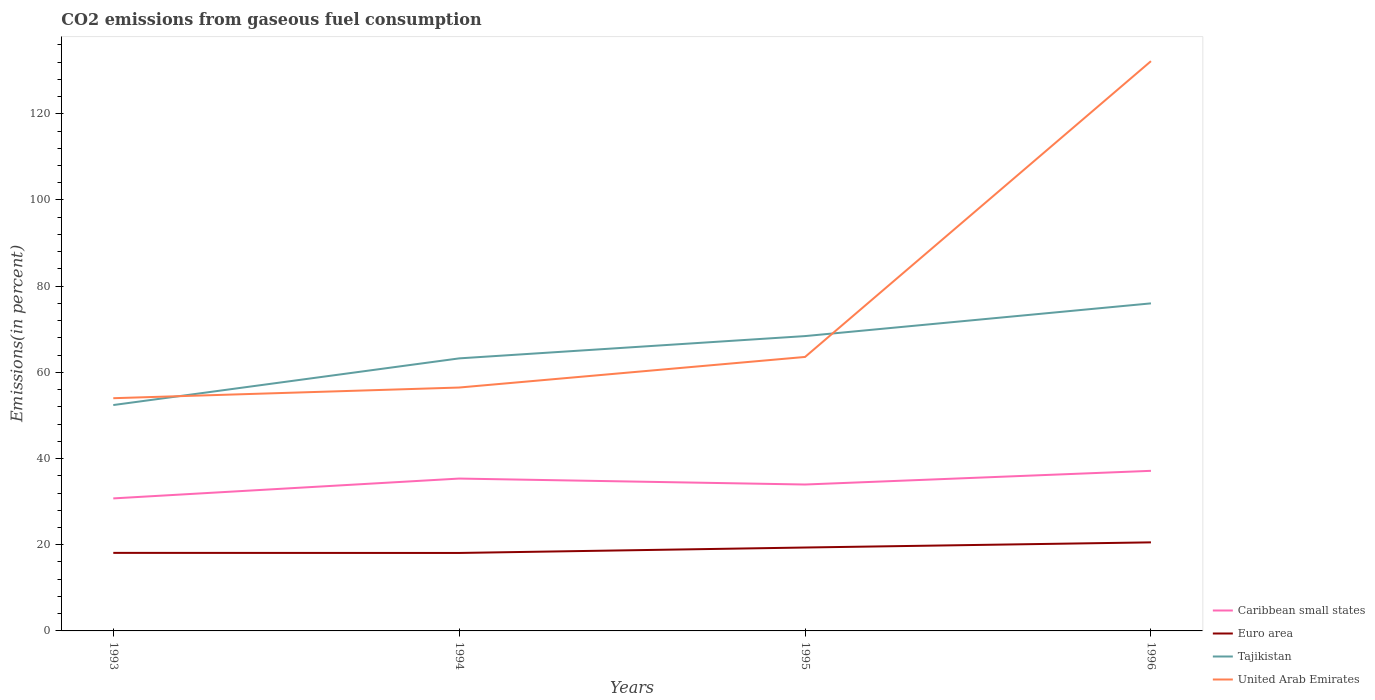How many different coloured lines are there?
Your answer should be very brief. 4. Does the line corresponding to Tajikistan intersect with the line corresponding to United Arab Emirates?
Offer a very short reply. Yes. Across all years, what is the maximum total CO2 emitted in Euro area?
Your response must be concise. 18.09. In which year was the total CO2 emitted in United Arab Emirates maximum?
Ensure brevity in your answer.  1993. What is the total total CO2 emitted in United Arab Emirates in the graph?
Keep it short and to the point. -2.48. What is the difference between the highest and the second highest total CO2 emitted in United Arab Emirates?
Ensure brevity in your answer.  78.21. How many years are there in the graph?
Provide a short and direct response. 4. What is the difference between two consecutive major ticks on the Y-axis?
Offer a terse response. 20. Are the values on the major ticks of Y-axis written in scientific E-notation?
Give a very brief answer. No. Where does the legend appear in the graph?
Your answer should be very brief. Bottom right. How many legend labels are there?
Provide a succinct answer. 4. How are the legend labels stacked?
Offer a very short reply. Vertical. What is the title of the graph?
Provide a succinct answer. CO2 emissions from gaseous fuel consumption. Does "Congo (Republic)" appear as one of the legend labels in the graph?
Your response must be concise. No. What is the label or title of the Y-axis?
Your response must be concise. Emissions(in percent). What is the Emissions(in percent) of Caribbean small states in 1993?
Give a very brief answer. 30.75. What is the Emissions(in percent) in Euro area in 1993?
Give a very brief answer. 18.11. What is the Emissions(in percent) in Tajikistan in 1993?
Keep it short and to the point. 52.41. What is the Emissions(in percent) of United Arab Emirates in 1993?
Ensure brevity in your answer.  54. What is the Emissions(in percent) in Caribbean small states in 1994?
Your response must be concise. 35.35. What is the Emissions(in percent) of Euro area in 1994?
Provide a short and direct response. 18.09. What is the Emissions(in percent) of Tajikistan in 1994?
Give a very brief answer. 63.24. What is the Emissions(in percent) in United Arab Emirates in 1994?
Make the answer very short. 56.48. What is the Emissions(in percent) of Caribbean small states in 1995?
Offer a terse response. 33.97. What is the Emissions(in percent) of Euro area in 1995?
Your answer should be compact. 19.35. What is the Emissions(in percent) of Tajikistan in 1995?
Your answer should be very brief. 68.41. What is the Emissions(in percent) of United Arab Emirates in 1995?
Your response must be concise. 63.57. What is the Emissions(in percent) in Caribbean small states in 1996?
Give a very brief answer. 37.15. What is the Emissions(in percent) of Euro area in 1996?
Give a very brief answer. 20.55. What is the Emissions(in percent) in Tajikistan in 1996?
Provide a succinct answer. 76.01. What is the Emissions(in percent) in United Arab Emirates in 1996?
Your answer should be compact. 132.21. Across all years, what is the maximum Emissions(in percent) in Caribbean small states?
Provide a succinct answer. 37.15. Across all years, what is the maximum Emissions(in percent) in Euro area?
Provide a succinct answer. 20.55. Across all years, what is the maximum Emissions(in percent) in Tajikistan?
Your answer should be very brief. 76.01. Across all years, what is the maximum Emissions(in percent) of United Arab Emirates?
Provide a succinct answer. 132.21. Across all years, what is the minimum Emissions(in percent) of Caribbean small states?
Make the answer very short. 30.75. Across all years, what is the minimum Emissions(in percent) in Euro area?
Offer a terse response. 18.09. Across all years, what is the minimum Emissions(in percent) in Tajikistan?
Provide a succinct answer. 52.41. Across all years, what is the minimum Emissions(in percent) of United Arab Emirates?
Make the answer very short. 54. What is the total Emissions(in percent) of Caribbean small states in the graph?
Keep it short and to the point. 137.22. What is the total Emissions(in percent) in Euro area in the graph?
Your response must be concise. 76.1. What is the total Emissions(in percent) of Tajikistan in the graph?
Your answer should be compact. 260.07. What is the total Emissions(in percent) of United Arab Emirates in the graph?
Give a very brief answer. 306.25. What is the difference between the Emissions(in percent) in Caribbean small states in 1993 and that in 1994?
Offer a very short reply. -4.6. What is the difference between the Emissions(in percent) of Euro area in 1993 and that in 1994?
Make the answer very short. 0.02. What is the difference between the Emissions(in percent) of Tajikistan in 1993 and that in 1994?
Your answer should be compact. -10.83. What is the difference between the Emissions(in percent) in United Arab Emirates in 1993 and that in 1994?
Ensure brevity in your answer.  -2.48. What is the difference between the Emissions(in percent) in Caribbean small states in 1993 and that in 1995?
Give a very brief answer. -3.22. What is the difference between the Emissions(in percent) of Euro area in 1993 and that in 1995?
Give a very brief answer. -1.24. What is the difference between the Emissions(in percent) of Tajikistan in 1993 and that in 1995?
Ensure brevity in your answer.  -16. What is the difference between the Emissions(in percent) in United Arab Emirates in 1993 and that in 1995?
Your answer should be very brief. -9.58. What is the difference between the Emissions(in percent) of Caribbean small states in 1993 and that in 1996?
Your response must be concise. -6.4. What is the difference between the Emissions(in percent) of Euro area in 1993 and that in 1996?
Offer a terse response. -2.44. What is the difference between the Emissions(in percent) of Tajikistan in 1993 and that in 1996?
Offer a terse response. -23.59. What is the difference between the Emissions(in percent) in United Arab Emirates in 1993 and that in 1996?
Your response must be concise. -78.21. What is the difference between the Emissions(in percent) in Caribbean small states in 1994 and that in 1995?
Provide a succinct answer. 1.38. What is the difference between the Emissions(in percent) in Euro area in 1994 and that in 1995?
Your answer should be very brief. -1.26. What is the difference between the Emissions(in percent) of Tajikistan in 1994 and that in 1995?
Make the answer very short. -5.17. What is the difference between the Emissions(in percent) in United Arab Emirates in 1994 and that in 1995?
Offer a terse response. -7.1. What is the difference between the Emissions(in percent) in Caribbean small states in 1994 and that in 1996?
Offer a very short reply. -1.79. What is the difference between the Emissions(in percent) in Euro area in 1994 and that in 1996?
Make the answer very short. -2.46. What is the difference between the Emissions(in percent) of Tajikistan in 1994 and that in 1996?
Make the answer very short. -12.77. What is the difference between the Emissions(in percent) in United Arab Emirates in 1994 and that in 1996?
Offer a very short reply. -75.73. What is the difference between the Emissions(in percent) of Caribbean small states in 1995 and that in 1996?
Provide a short and direct response. -3.18. What is the difference between the Emissions(in percent) of Euro area in 1995 and that in 1996?
Give a very brief answer. -1.2. What is the difference between the Emissions(in percent) of Tajikistan in 1995 and that in 1996?
Give a very brief answer. -7.59. What is the difference between the Emissions(in percent) of United Arab Emirates in 1995 and that in 1996?
Offer a terse response. -68.63. What is the difference between the Emissions(in percent) of Caribbean small states in 1993 and the Emissions(in percent) of Euro area in 1994?
Offer a terse response. 12.66. What is the difference between the Emissions(in percent) of Caribbean small states in 1993 and the Emissions(in percent) of Tajikistan in 1994?
Ensure brevity in your answer.  -32.49. What is the difference between the Emissions(in percent) in Caribbean small states in 1993 and the Emissions(in percent) in United Arab Emirates in 1994?
Provide a short and direct response. -25.73. What is the difference between the Emissions(in percent) of Euro area in 1993 and the Emissions(in percent) of Tajikistan in 1994?
Offer a terse response. -45.13. What is the difference between the Emissions(in percent) in Euro area in 1993 and the Emissions(in percent) in United Arab Emirates in 1994?
Your answer should be very brief. -38.37. What is the difference between the Emissions(in percent) in Tajikistan in 1993 and the Emissions(in percent) in United Arab Emirates in 1994?
Your response must be concise. -4.06. What is the difference between the Emissions(in percent) of Caribbean small states in 1993 and the Emissions(in percent) of Euro area in 1995?
Give a very brief answer. 11.4. What is the difference between the Emissions(in percent) of Caribbean small states in 1993 and the Emissions(in percent) of Tajikistan in 1995?
Your response must be concise. -37.66. What is the difference between the Emissions(in percent) in Caribbean small states in 1993 and the Emissions(in percent) in United Arab Emirates in 1995?
Provide a short and direct response. -32.83. What is the difference between the Emissions(in percent) in Euro area in 1993 and the Emissions(in percent) in Tajikistan in 1995?
Your response must be concise. -50.3. What is the difference between the Emissions(in percent) in Euro area in 1993 and the Emissions(in percent) in United Arab Emirates in 1995?
Ensure brevity in your answer.  -45.47. What is the difference between the Emissions(in percent) of Tajikistan in 1993 and the Emissions(in percent) of United Arab Emirates in 1995?
Offer a very short reply. -11.16. What is the difference between the Emissions(in percent) in Caribbean small states in 1993 and the Emissions(in percent) in Euro area in 1996?
Your answer should be very brief. 10.2. What is the difference between the Emissions(in percent) of Caribbean small states in 1993 and the Emissions(in percent) of Tajikistan in 1996?
Your answer should be compact. -45.26. What is the difference between the Emissions(in percent) of Caribbean small states in 1993 and the Emissions(in percent) of United Arab Emirates in 1996?
Ensure brevity in your answer.  -101.46. What is the difference between the Emissions(in percent) of Euro area in 1993 and the Emissions(in percent) of Tajikistan in 1996?
Your response must be concise. -57.9. What is the difference between the Emissions(in percent) of Euro area in 1993 and the Emissions(in percent) of United Arab Emirates in 1996?
Keep it short and to the point. -114.1. What is the difference between the Emissions(in percent) of Tajikistan in 1993 and the Emissions(in percent) of United Arab Emirates in 1996?
Your answer should be very brief. -79.79. What is the difference between the Emissions(in percent) of Caribbean small states in 1994 and the Emissions(in percent) of Euro area in 1995?
Provide a succinct answer. 16. What is the difference between the Emissions(in percent) in Caribbean small states in 1994 and the Emissions(in percent) in Tajikistan in 1995?
Your response must be concise. -33.06. What is the difference between the Emissions(in percent) of Caribbean small states in 1994 and the Emissions(in percent) of United Arab Emirates in 1995?
Provide a succinct answer. -28.22. What is the difference between the Emissions(in percent) in Euro area in 1994 and the Emissions(in percent) in Tajikistan in 1995?
Offer a very short reply. -50.32. What is the difference between the Emissions(in percent) in Euro area in 1994 and the Emissions(in percent) in United Arab Emirates in 1995?
Your answer should be very brief. -45.48. What is the difference between the Emissions(in percent) in Tajikistan in 1994 and the Emissions(in percent) in United Arab Emirates in 1995?
Keep it short and to the point. -0.33. What is the difference between the Emissions(in percent) of Caribbean small states in 1994 and the Emissions(in percent) of Euro area in 1996?
Provide a short and direct response. 14.8. What is the difference between the Emissions(in percent) of Caribbean small states in 1994 and the Emissions(in percent) of Tajikistan in 1996?
Offer a terse response. -40.65. What is the difference between the Emissions(in percent) in Caribbean small states in 1994 and the Emissions(in percent) in United Arab Emirates in 1996?
Give a very brief answer. -96.85. What is the difference between the Emissions(in percent) of Euro area in 1994 and the Emissions(in percent) of Tajikistan in 1996?
Keep it short and to the point. -57.91. What is the difference between the Emissions(in percent) of Euro area in 1994 and the Emissions(in percent) of United Arab Emirates in 1996?
Provide a short and direct response. -114.11. What is the difference between the Emissions(in percent) of Tajikistan in 1994 and the Emissions(in percent) of United Arab Emirates in 1996?
Offer a very short reply. -68.97. What is the difference between the Emissions(in percent) in Caribbean small states in 1995 and the Emissions(in percent) in Euro area in 1996?
Make the answer very short. 13.42. What is the difference between the Emissions(in percent) of Caribbean small states in 1995 and the Emissions(in percent) of Tajikistan in 1996?
Provide a succinct answer. -42.03. What is the difference between the Emissions(in percent) in Caribbean small states in 1995 and the Emissions(in percent) in United Arab Emirates in 1996?
Make the answer very short. -98.23. What is the difference between the Emissions(in percent) in Euro area in 1995 and the Emissions(in percent) in Tajikistan in 1996?
Offer a terse response. -56.65. What is the difference between the Emissions(in percent) of Euro area in 1995 and the Emissions(in percent) of United Arab Emirates in 1996?
Your answer should be very brief. -112.85. What is the difference between the Emissions(in percent) of Tajikistan in 1995 and the Emissions(in percent) of United Arab Emirates in 1996?
Your response must be concise. -63.79. What is the average Emissions(in percent) in Caribbean small states per year?
Offer a terse response. 34.3. What is the average Emissions(in percent) in Euro area per year?
Your response must be concise. 19.03. What is the average Emissions(in percent) of Tajikistan per year?
Provide a succinct answer. 65.02. What is the average Emissions(in percent) in United Arab Emirates per year?
Your answer should be very brief. 76.56. In the year 1993, what is the difference between the Emissions(in percent) of Caribbean small states and Emissions(in percent) of Euro area?
Offer a terse response. 12.64. In the year 1993, what is the difference between the Emissions(in percent) of Caribbean small states and Emissions(in percent) of Tajikistan?
Keep it short and to the point. -21.66. In the year 1993, what is the difference between the Emissions(in percent) of Caribbean small states and Emissions(in percent) of United Arab Emirates?
Provide a succinct answer. -23.25. In the year 1993, what is the difference between the Emissions(in percent) in Euro area and Emissions(in percent) in Tajikistan?
Provide a succinct answer. -34.3. In the year 1993, what is the difference between the Emissions(in percent) of Euro area and Emissions(in percent) of United Arab Emirates?
Offer a very short reply. -35.89. In the year 1993, what is the difference between the Emissions(in percent) in Tajikistan and Emissions(in percent) in United Arab Emirates?
Your answer should be very brief. -1.59. In the year 1994, what is the difference between the Emissions(in percent) of Caribbean small states and Emissions(in percent) of Euro area?
Provide a short and direct response. 17.26. In the year 1994, what is the difference between the Emissions(in percent) of Caribbean small states and Emissions(in percent) of Tajikistan?
Provide a short and direct response. -27.89. In the year 1994, what is the difference between the Emissions(in percent) in Caribbean small states and Emissions(in percent) in United Arab Emirates?
Offer a very short reply. -21.12. In the year 1994, what is the difference between the Emissions(in percent) in Euro area and Emissions(in percent) in Tajikistan?
Provide a succinct answer. -45.15. In the year 1994, what is the difference between the Emissions(in percent) of Euro area and Emissions(in percent) of United Arab Emirates?
Your response must be concise. -38.38. In the year 1994, what is the difference between the Emissions(in percent) in Tajikistan and Emissions(in percent) in United Arab Emirates?
Keep it short and to the point. 6.76. In the year 1995, what is the difference between the Emissions(in percent) of Caribbean small states and Emissions(in percent) of Euro area?
Give a very brief answer. 14.62. In the year 1995, what is the difference between the Emissions(in percent) of Caribbean small states and Emissions(in percent) of Tajikistan?
Offer a very short reply. -34.44. In the year 1995, what is the difference between the Emissions(in percent) of Caribbean small states and Emissions(in percent) of United Arab Emirates?
Offer a very short reply. -29.6. In the year 1995, what is the difference between the Emissions(in percent) of Euro area and Emissions(in percent) of Tajikistan?
Give a very brief answer. -49.06. In the year 1995, what is the difference between the Emissions(in percent) in Euro area and Emissions(in percent) in United Arab Emirates?
Your answer should be very brief. -44.22. In the year 1995, what is the difference between the Emissions(in percent) of Tajikistan and Emissions(in percent) of United Arab Emirates?
Your answer should be very brief. 4.84. In the year 1996, what is the difference between the Emissions(in percent) of Caribbean small states and Emissions(in percent) of Euro area?
Make the answer very short. 16.6. In the year 1996, what is the difference between the Emissions(in percent) of Caribbean small states and Emissions(in percent) of Tajikistan?
Provide a short and direct response. -38.86. In the year 1996, what is the difference between the Emissions(in percent) in Caribbean small states and Emissions(in percent) in United Arab Emirates?
Provide a succinct answer. -95.06. In the year 1996, what is the difference between the Emissions(in percent) of Euro area and Emissions(in percent) of Tajikistan?
Your response must be concise. -55.46. In the year 1996, what is the difference between the Emissions(in percent) in Euro area and Emissions(in percent) in United Arab Emirates?
Provide a succinct answer. -111.66. In the year 1996, what is the difference between the Emissions(in percent) of Tajikistan and Emissions(in percent) of United Arab Emirates?
Keep it short and to the point. -56.2. What is the ratio of the Emissions(in percent) in Caribbean small states in 1993 to that in 1994?
Your response must be concise. 0.87. What is the ratio of the Emissions(in percent) of Tajikistan in 1993 to that in 1994?
Make the answer very short. 0.83. What is the ratio of the Emissions(in percent) of United Arab Emirates in 1993 to that in 1994?
Offer a very short reply. 0.96. What is the ratio of the Emissions(in percent) of Caribbean small states in 1993 to that in 1995?
Give a very brief answer. 0.91. What is the ratio of the Emissions(in percent) in Euro area in 1993 to that in 1995?
Offer a very short reply. 0.94. What is the ratio of the Emissions(in percent) of Tajikistan in 1993 to that in 1995?
Provide a succinct answer. 0.77. What is the ratio of the Emissions(in percent) of United Arab Emirates in 1993 to that in 1995?
Offer a terse response. 0.85. What is the ratio of the Emissions(in percent) of Caribbean small states in 1993 to that in 1996?
Your answer should be compact. 0.83. What is the ratio of the Emissions(in percent) in Euro area in 1993 to that in 1996?
Make the answer very short. 0.88. What is the ratio of the Emissions(in percent) in Tajikistan in 1993 to that in 1996?
Ensure brevity in your answer.  0.69. What is the ratio of the Emissions(in percent) of United Arab Emirates in 1993 to that in 1996?
Offer a terse response. 0.41. What is the ratio of the Emissions(in percent) of Caribbean small states in 1994 to that in 1995?
Make the answer very short. 1.04. What is the ratio of the Emissions(in percent) of Euro area in 1994 to that in 1995?
Make the answer very short. 0.93. What is the ratio of the Emissions(in percent) in Tajikistan in 1994 to that in 1995?
Your response must be concise. 0.92. What is the ratio of the Emissions(in percent) in United Arab Emirates in 1994 to that in 1995?
Ensure brevity in your answer.  0.89. What is the ratio of the Emissions(in percent) in Caribbean small states in 1994 to that in 1996?
Provide a short and direct response. 0.95. What is the ratio of the Emissions(in percent) of Euro area in 1994 to that in 1996?
Your answer should be very brief. 0.88. What is the ratio of the Emissions(in percent) in Tajikistan in 1994 to that in 1996?
Offer a very short reply. 0.83. What is the ratio of the Emissions(in percent) in United Arab Emirates in 1994 to that in 1996?
Your answer should be very brief. 0.43. What is the ratio of the Emissions(in percent) in Caribbean small states in 1995 to that in 1996?
Your answer should be very brief. 0.91. What is the ratio of the Emissions(in percent) of Euro area in 1995 to that in 1996?
Make the answer very short. 0.94. What is the ratio of the Emissions(in percent) of Tajikistan in 1995 to that in 1996?
Make the answer very short. 0.9. What is the ratio of the Emissions(in percent) in United Arab Emirates in 1995 to that in 1996?
Give a very brief answer. 0.48. What is the difference between the highest and the second highest Emissions(in percent) of Caribbean small states?
Offer a terse response. 1.79. What is the difference between the highest and the second highest Emissions(in percent) in Euro area?
Provide a succinct answer. 1.2. What is the difference between the highest and the second highest Emissions(in percent) of Tajikistan?
Ensure brevity in your answer.  7.59. What is the difference between the highest and the second highest Emissions(in percent) of United Arab Emirates?
Make the answer very short. 68.63. What is the difference between the highest and the lowest Emissions(in percent) of Caribbean small states?
Your answer should be compact. 6.4. What is the difference between the highest and the lowest Emissions(in percent) of Euro area?
Keep it short and to the point. 2.46. What is the difference between the highest and the lowest Emissions(in percent) in Tajikistan?
Provide a succinct answer. 23.59. What is the difference between the highest and the lowest Emissions(in percent) of United Arab Emirates?
Keep it short and to the point. 78.21. 